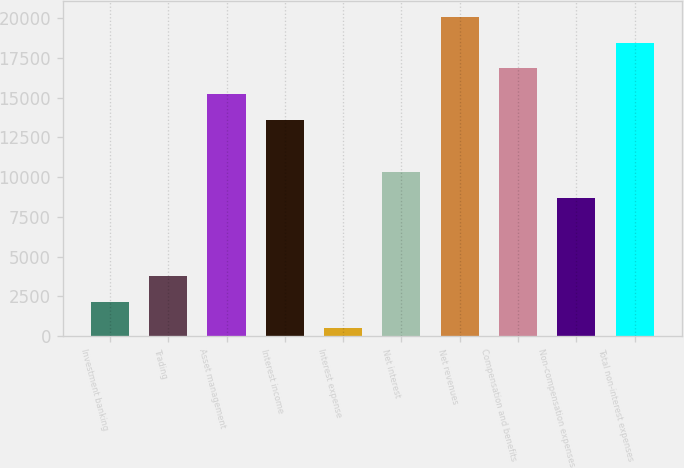Convert chart to OTSL. <chart><loc_0><loc_0><loc_500><loc_500><bar_chart><fcel>Investment banking<fcel>Trading<fcel>Asset management<fcel>Interest income<fcel>Interest expense<fcel>Net interest<fcel>Net revenues<fcel>Compensation and benefits<fcel>Non-compensation expenses<fcel>Total non-interest expenses<nl><fcel>2121<fcel>3756<fcel>15201<fcel>13566<fcel>486<fcel>10296<fcel>20106<fcel>16836<fcel>8661<fcel>18471<nl></chart> 